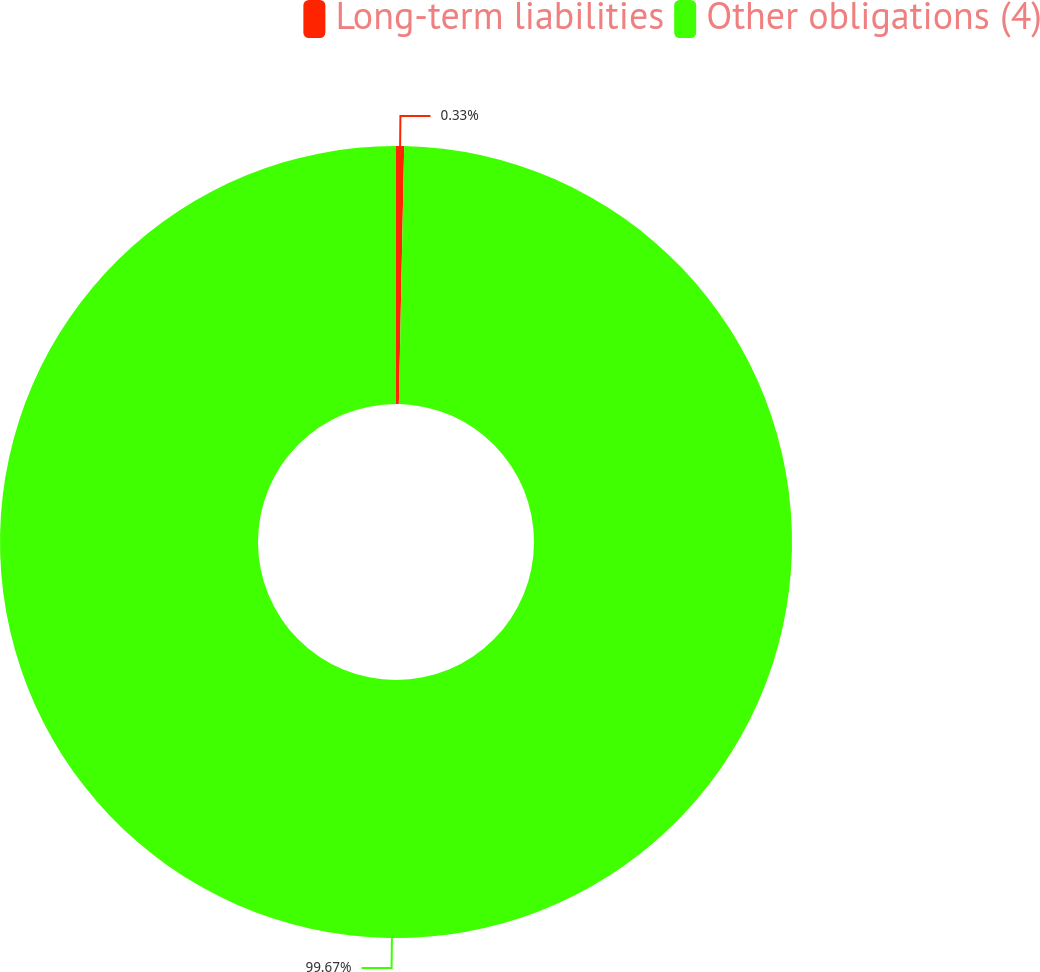Convert chart. <chart><loc_0><loc_0><loc_500><loc_500><pie_chart><fcel>Long-term liabilities<fcel>Other obligations (4)<nl><fcel>0.33%<fcel>99.67%<nl></chart> 